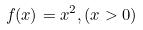<formula> <loc_0><loc_0><loc_500><loc_500>f ( x ) = x ^ { 2 } , ( x > 0 )</formula> 